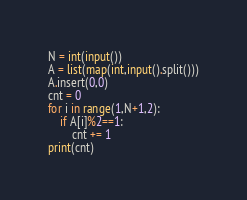<code> <loc_0><loc_0><loc_500><loc_500><_Python_>N = int(input())
A = list(map(int,input().split()))
A.insert(0,0)
cnt = 0
for i in range(1,N+1,2):
    if A[i]%2==1:
        cnt += 1
print(cnt)</code> 